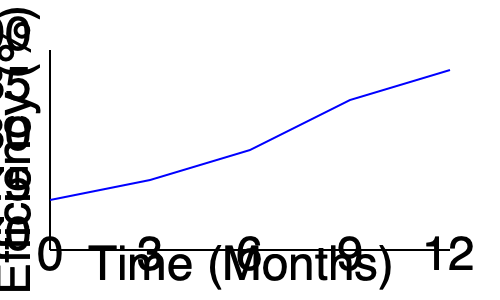Based on the production efficiency graph, what is the approximate percentage increase in efficiency from the start of the year to the end of the year? To calculate the percentage increase in efficiency:

1. Identify the starting efficiency (at 0 months): approximately 75%
2. Identify the ending efficiency (at 12 months): approximately 87%
3. Calculate the absolute increase: 87% - 75% = 12%
4. Calculate the percentage increase:
   $\frac{\text{Increase}}{\text{Original Value}} \times 100\% = \frac{12}{75} \times 100\% \approx 16\%$

The efficiency increased by approximately 16% from the start to the end of the year.
Answer: 16% 